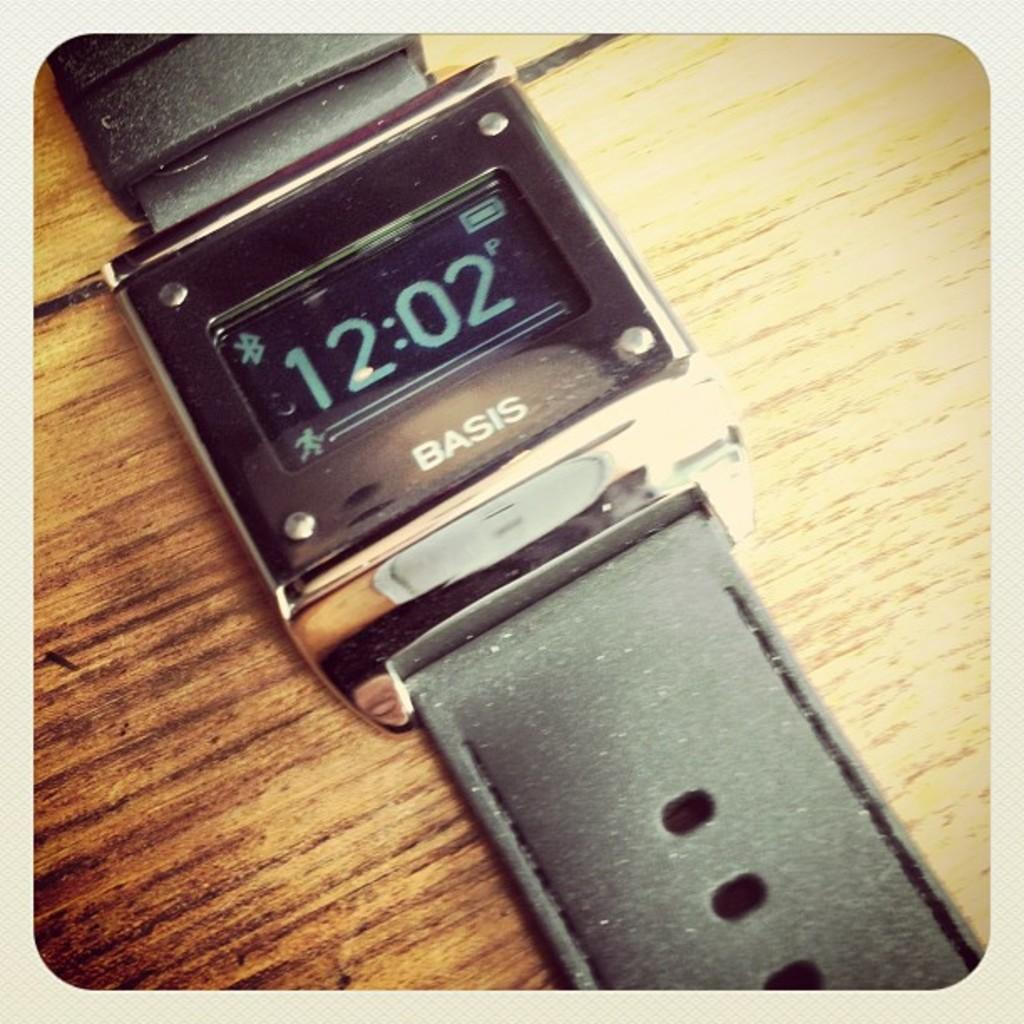<image>
Offer a succinct explanation of the picture presented. a Basis digital watch with a square face is laying on a wooden table 